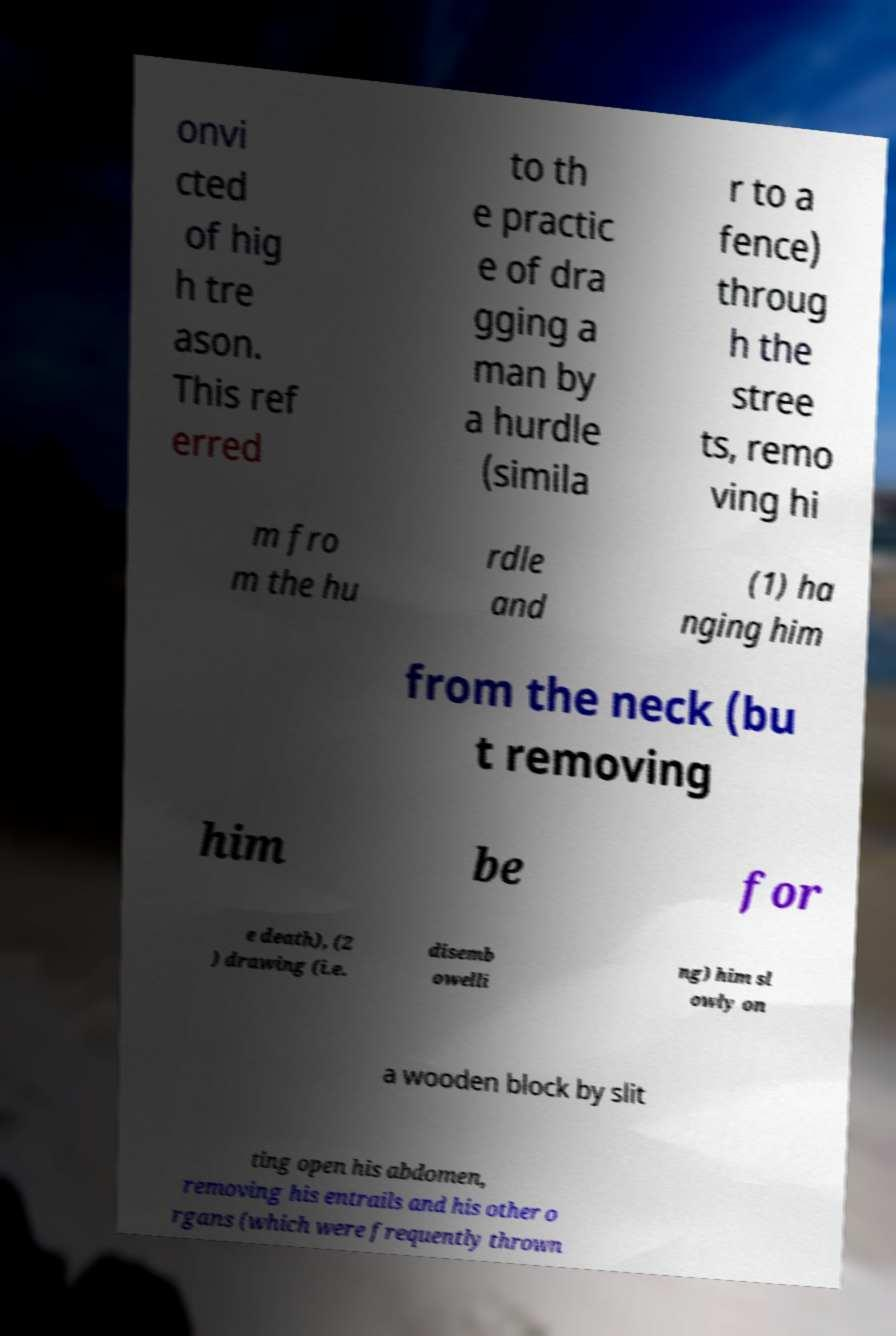What messages or text are displayed in this image? I need them in a readable, typed format. onvi cted of hig h tre ason. This ref erred to th e practic e of dra gging a man by a hurdle (simila r to a fence) throug h the stree ts, remo ving hi m fro m the hu rdle and (1) ha nging him from the neck (bu t removing him be for e death), (2 ) drawing (i.e. disemb owelli ng) him sl owly on a wooden block by slit ting open his abdomen, removing his entrails and his other o rgans (which were frequently thrown 